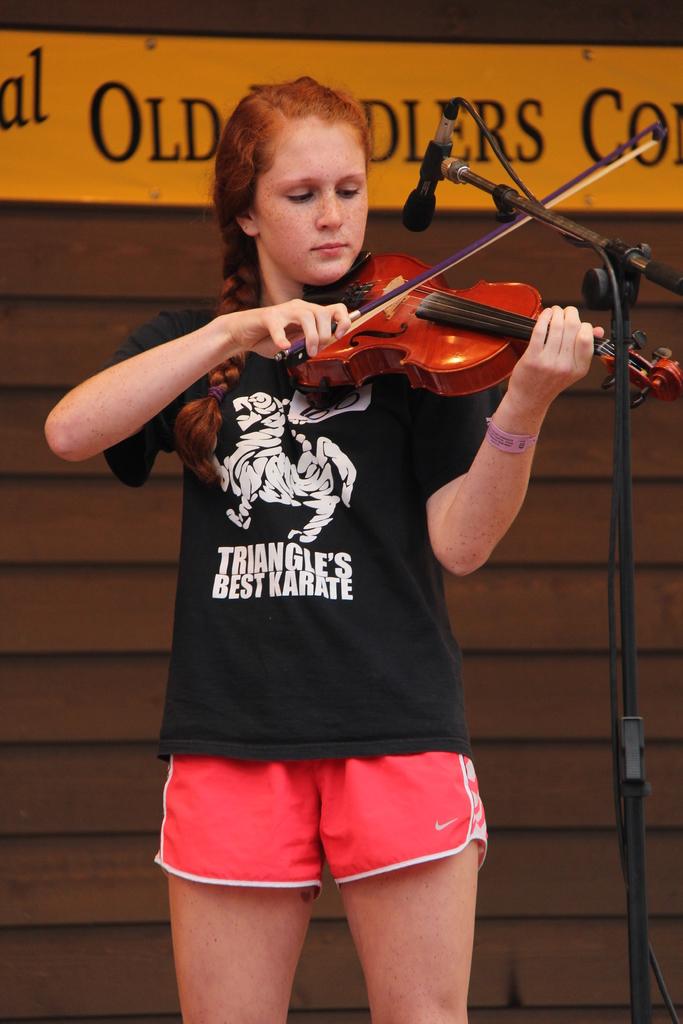What sport is indicated on the t-shirt?
Keep it short and to the point. Karate. What is the name on the shirt?
Offer a very short reply. Triangle's best karate. 